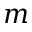Convert formula to latex. <formula><loc_0><loc_0><loc_500><loc_500>m</formula> 